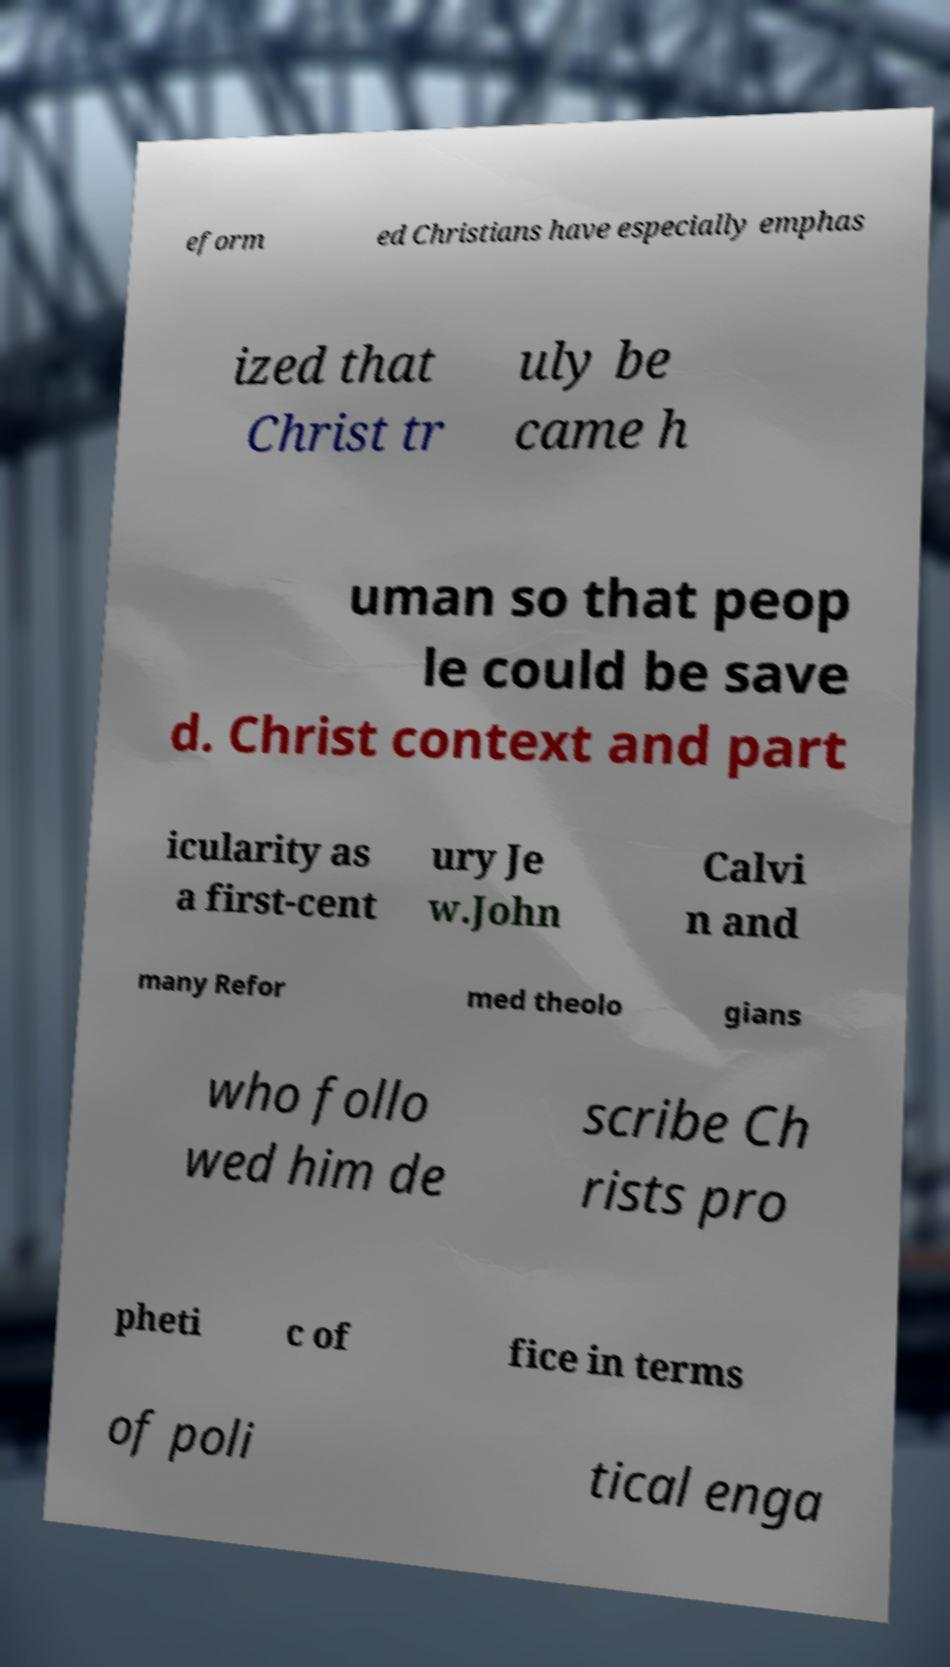I need the written content from this picture converted into text. Can you do that? eform ed Christians have especially emphas ized that Christ tr uly be came h uman so that peop le could be save d. Christ context and part icularity as a first-cent ury Je w.John Calvi n and many Refor med theolo gians who follo wed him de scribe Ch rists pro pheti c of fice in terms of poli tical enga 